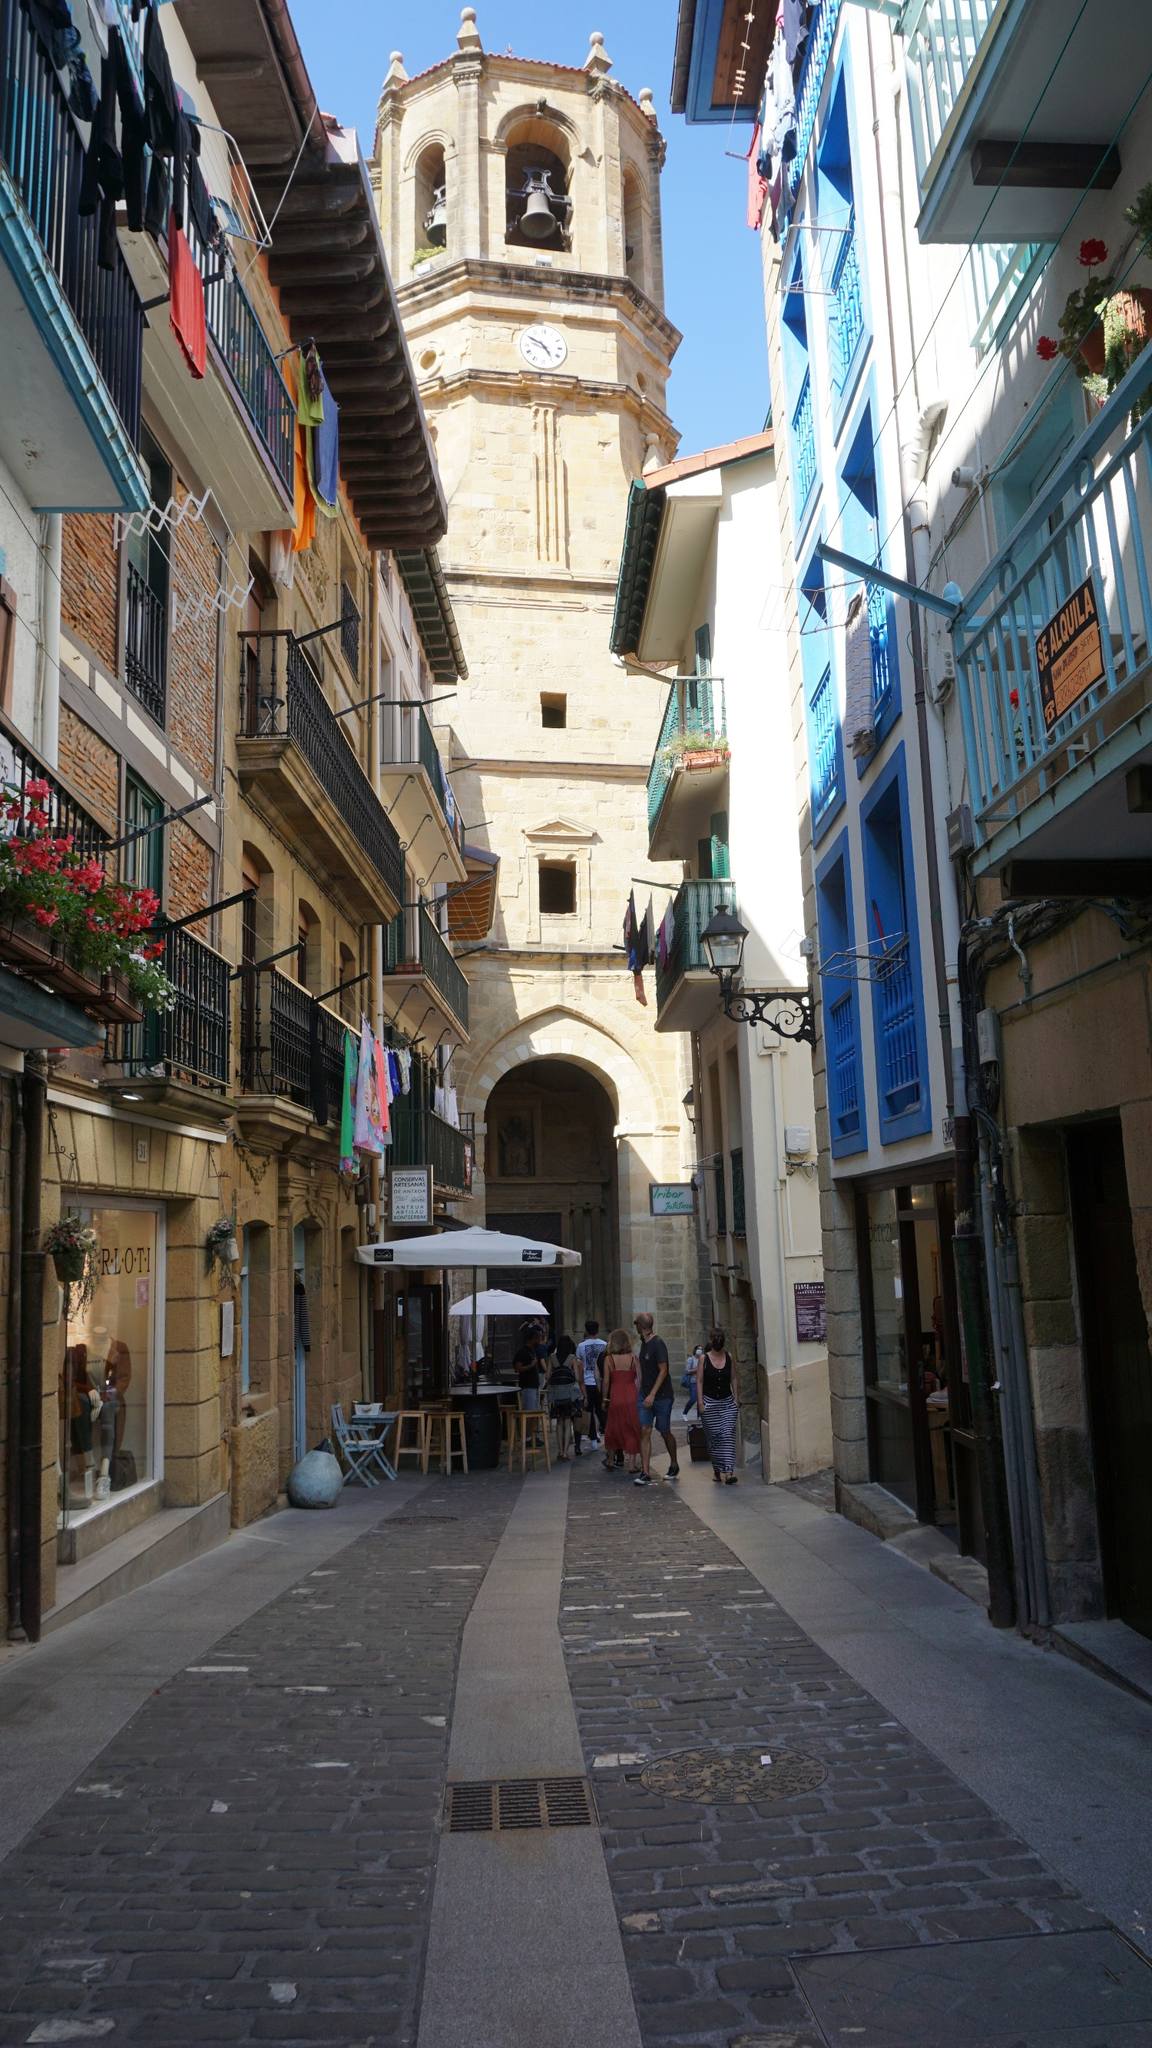Can you tell more about the architectural style visible in the buildings? The architectural style visible in these buildings is indicative of traditional European town architecture. Many structures feature elements typical of the early to mid-20th century urban European design, including use of color, wrought iron balconies, and detailed masonry. Notice the decorative facade treatments and the symmetrical window alignments that enhance the overall aesthetic appeal and reflect the region's historical influences and functional needs for sunlight and ventilation. 